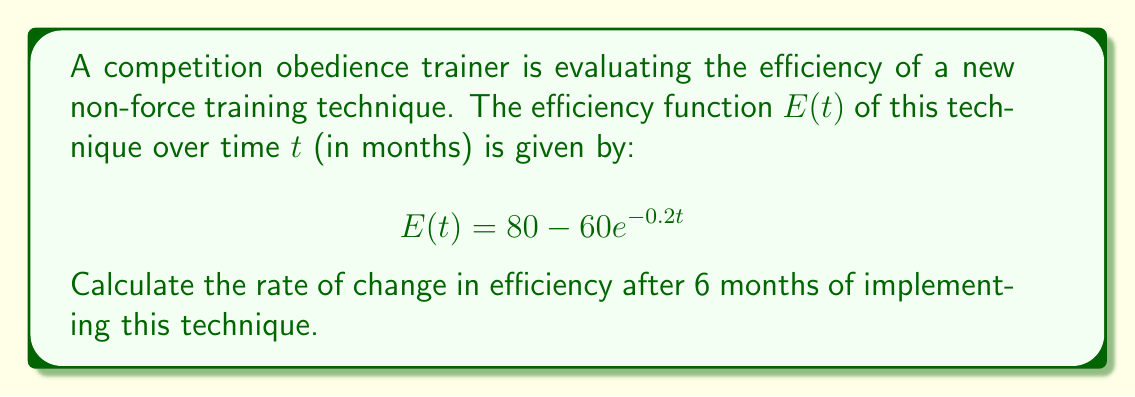Could you help me with this problem? To find the rate of change in efficiency after 6 months, we need to calculate the derivative of the efficiency function $E(t)$ and then evaluate it at $t=6$.

Step 1: Calculate the derivative of $E(t)$
$$\frac{d}{dt}E(t) = \frac{d}{dt}(80 - 60e^{-0.2t})$$

The derivative of a constant (80) is 0, so we only need to focus on the exponential term:
$$\frac{d}{dt}E(t) = -60 \cdot \frac{d}{dt}(e^{-0.2t})$$

Using the chain rule, we get:
$$\frac{d}{dt}E(t) = -60 \cdot (-0.2) \cdot e^{-0.2t}$$
$$\frac{d}{dt}E(t) = 12e^{-0.2t}$$

Step 2: Evaluate the derivative at $t=6$
$$\frac{d}{dt}E(6) = 12e^{-0.2(6)}$$
$$\frac{d}{dt}E(6) = 12e^{-1.2}$$
$$\frac{d}{dt}E(6) \approx 3.64$$

Therefore, the rate of change in efficiency after 6 months is approximately 3.64 units per month.
Answer: $3.64$ units per month 